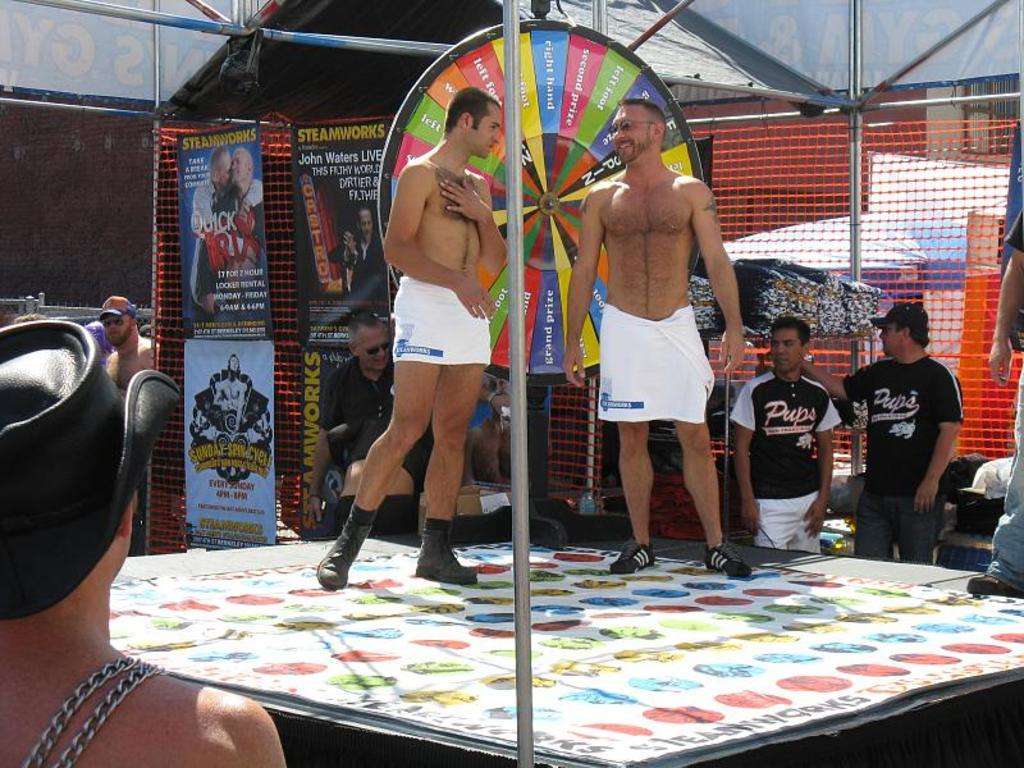<image>
Render a clear and concise summary of the photo. An outdoor event with two gentlemen wearing shirts that say "Pups" on them. 